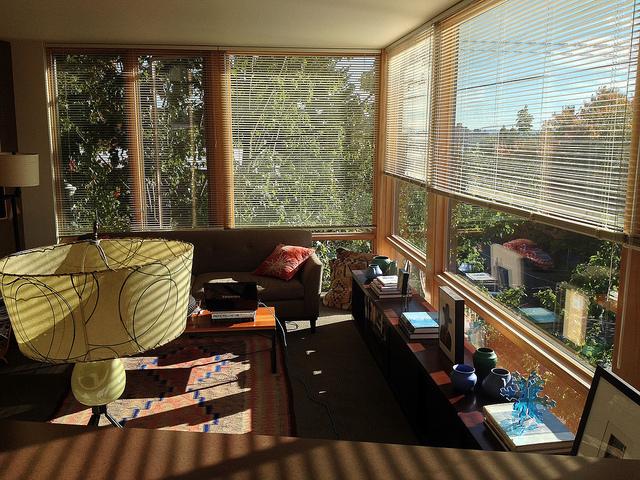What color is the lamp shade?
Be succinct. Yellow. Where is the laptop?
Short answer required. Coffee table. What is the laptop for?
Concise answer only. Work. 